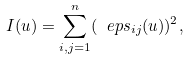<formula> <loc_0><loc_0><loc_500><loc_500>I ( u ) = \sum _ { i , j = 1 } ^ { n } ( \ e p s _ { i j } ( u ) ) ^ { 2 } ,</formula> 